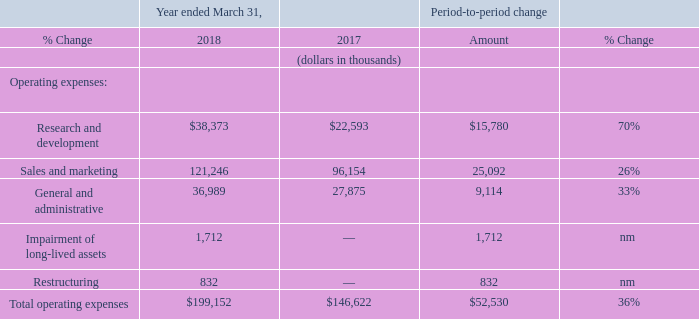Operating expenses
nm—not meaningful
Research and development expenses
Research and development expenses increased $15.8 million in the year ended March 31, 2018 compared to the year ended March 31, 2017, which was primarily attributable to increases in personnel-related costs of $10.1 million, information technology and facility costs of $2.3 million, professional services costs of $0.9 million, share-based compensation expense of $0.7 million, travel and other costs of $0.5 million and data center costs of $0.5 million.
Research and development expenses for the year ended March 31, 2018 as compared to the year ended March 31, 2017 were negatively impacted by approximately $0.5 million primarily as a result of the weakening of the U.S. dollar relative to the British pound.
Personnel-related cost increased primarily as a result of salaries and benefits associated with increased headcount throughout the year, information technology and facility costs increased primarily as a result of increased headcount, professional services costs increased primarily as a result of the use of research and development contractors and share-based compensation expense increased primarily as a result of share option grants since the prior year.
Sales and marketing expenses
Sales and marketing expenses increased $25.1 million in the year ended March 31, 2018 compared to the year ended March 31, 2017, which was primarily attributable to increases in personnel-related costs of $13.5 million, marketing costs of $4.7 million, information technology and facilities costs of $3.6 million, travel and other costs of $2.3 million and professional services of $0.8 million.
Sales and marketing expenses for the year ended March 31, 2018 as compared to the year ended March 31, 2017 were negatively impacted by approximately $1.4 million primarily as a result of the weakening of the U.S. dollar relative to the South African rand and British pound. Personnel-related costs increased primarily as a result of salaries and benefits associated with increased headcount. Information technology and facility costs and travel and other costs increased primarily as a result of increased headcount.
General and administrative expenses
General and administrative expenses increased $9.1 million in the year ended March 31, 2018 compared to the year ended March 31, 2017, which was primarily attributable to increases in personnel-related costs of $5.0 million, share-based compensation expense of $1.2 million, information technology and facilities costs of $1.0 million and professional services costs and material supplies of $0.6 million each.
General and administrative expenses for the year ended March 31, 2018 as compared to the year ended March 31, 2017 were negatively impacted by approximately $0.3 million primarily as a result of the weakening of the U.S. dollar against the British pound and South African rand. Personnel-related costs increased primarily as a result of salaries and benefits associated with increased headcount.
Share-based compensation expense increased primarily as a result of share option grants since the prior year. Information technology and facility and material supplies costs increased primarily as a result of increased headcount.
Restructuring and Impairment of long-lived assets
In the fourth quarter of fiscal 2018, upon the exit of our Watertown, Massachusetts corporate office space, we recorded a restructuring charge of $0.8 million for remaining non-cancelable rent and estimated operating expenses for the vacated premises, net of sublease rentals, and a non-cash impairment charge of $1.7 million primarily related to leasehold improvements.
What was the increase in Research and development expense in 2018? $15.8 million. What was the Sales and marketing expenses in 2018 and 2017 respectively?
Answer scale should be: thousand. 121,246, 96,154. What was the Research and development expenses in 2018 and 2017 respectively?
Answer scale should be: thousand. $38,373, $22,593. What was the average Research and development expenses in 2017 and 2018?
Answer scale should be: thousand. (38,373 + 22,593) / 2
Answer: 30483. What was the average Sales and marketing expenses in 2017 and 2018?
Answer scale should be: thousand. (121,246 + 96,154) / 2
Answer: 108700. In which year was General and administrative expenses less than 30,000 thousands? Locate and analyze general and administrative in row 7
answer: 2017. 